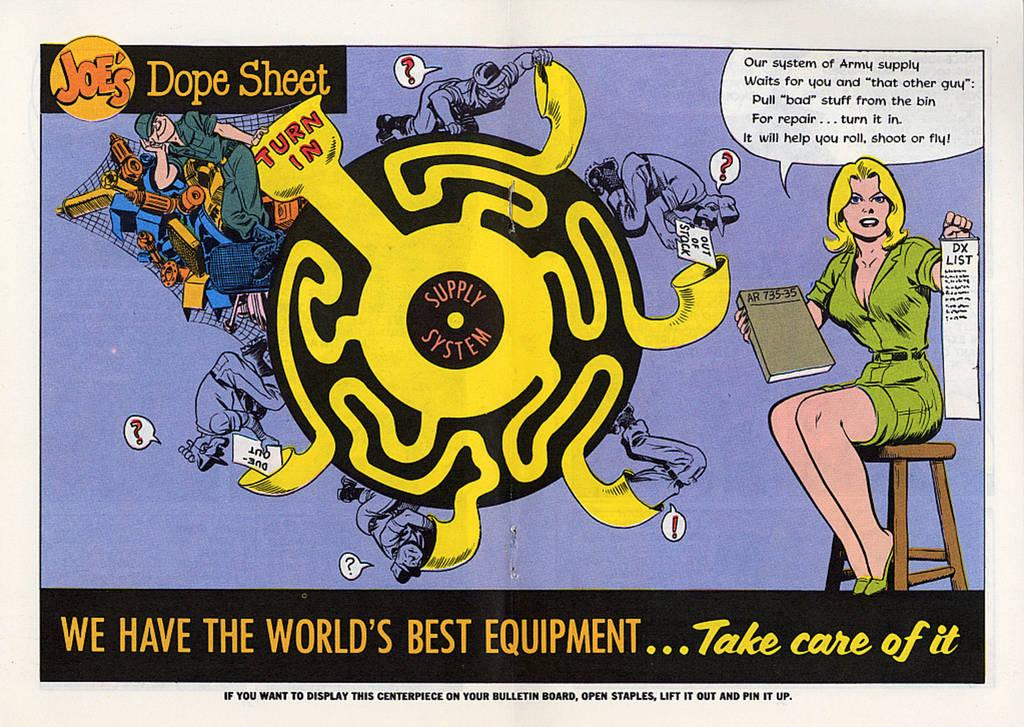<image>
Share a concise interpretation of the image provided. An old fashioned comic book illustration featuring a maze called Joe's Dope Sheet. 